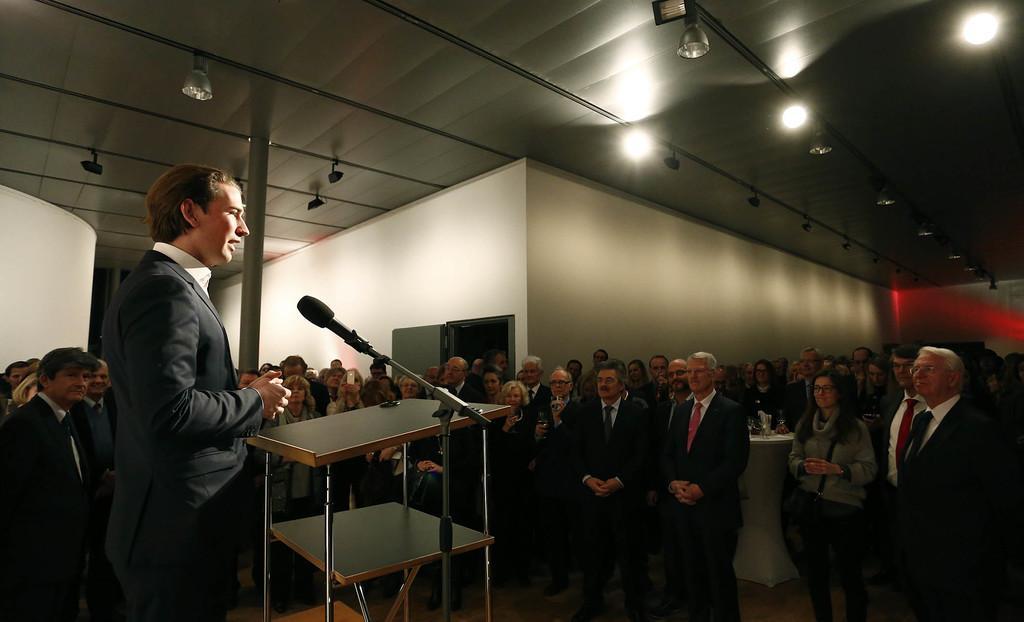Please provide a concise description of this image. This is a conference hall,many people are standing on the floor and listening to this person at the podium speaking on the microphone. At the rooftop we see few lights. 